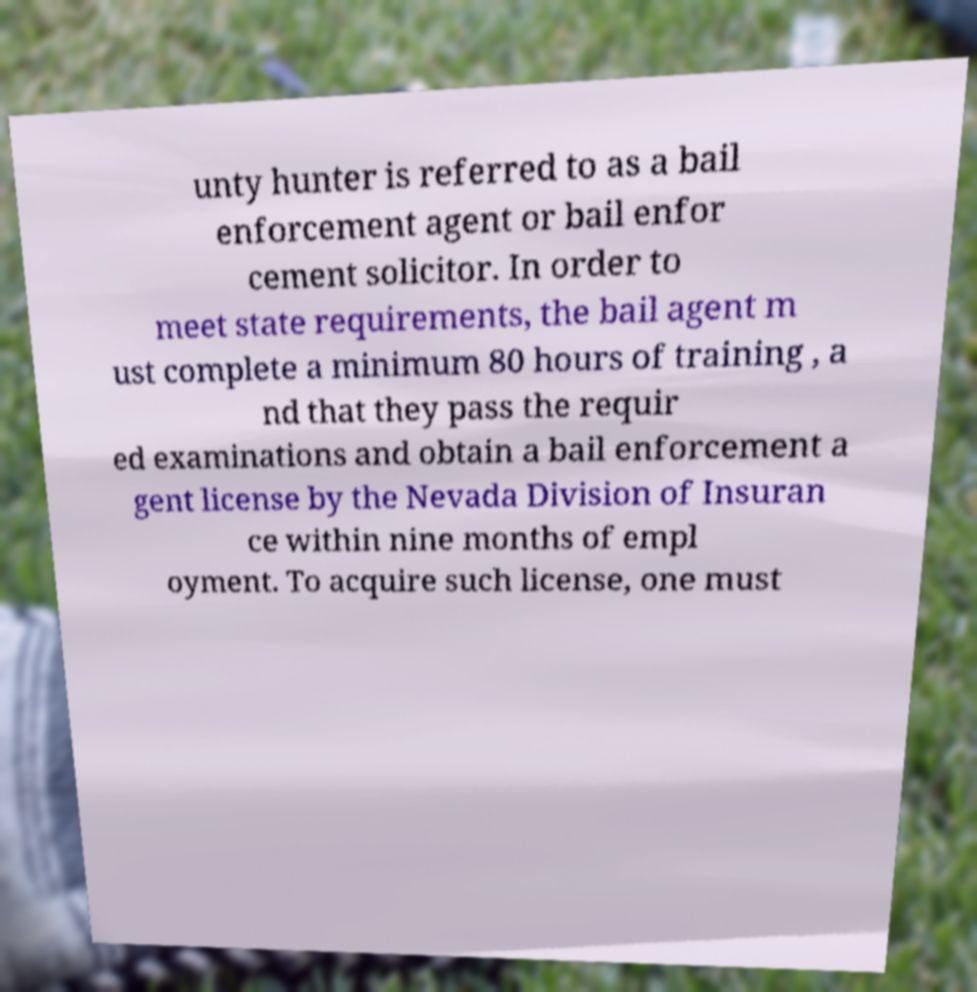Could you assist in decoding the text presented in this image and type it out clearly? unty hunter is referred to as a bail enforcement agent or bail enfor cement solicitor. In order to meet state requirements, the bail agent m ust complete a minimum 80 hours of training , a nd that they pass the requir ed examinations and obtain a bail enforcement a gent license by the Nevada Division of Insuran ce within nine months of empl oyment. To acquire such license, one must 